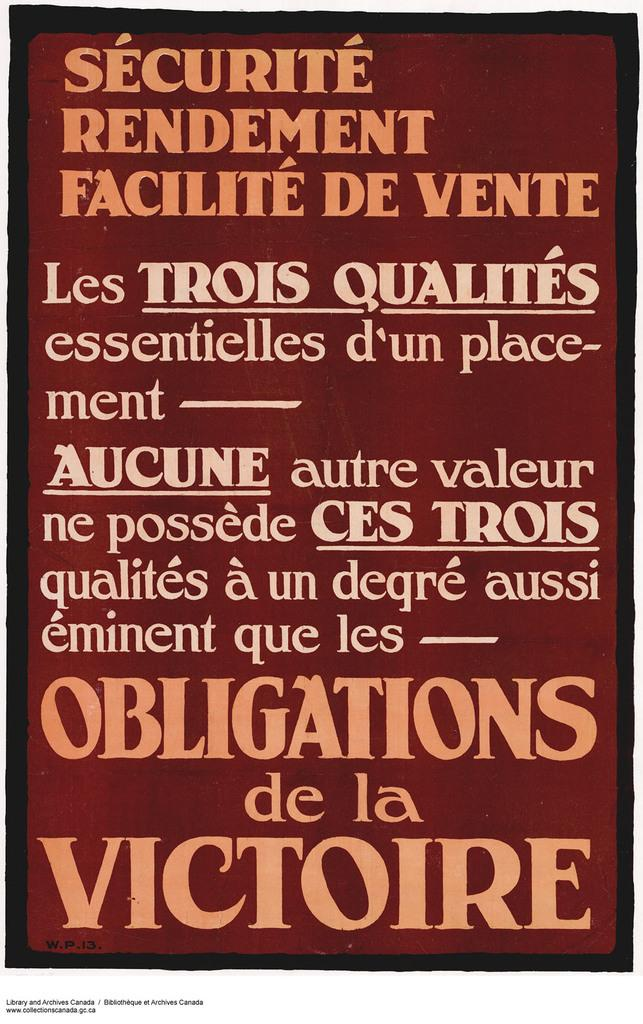<image>
Write a terse but informative summary of the picture. The cover of a book called Securite Rendement Faciilite De Vente 